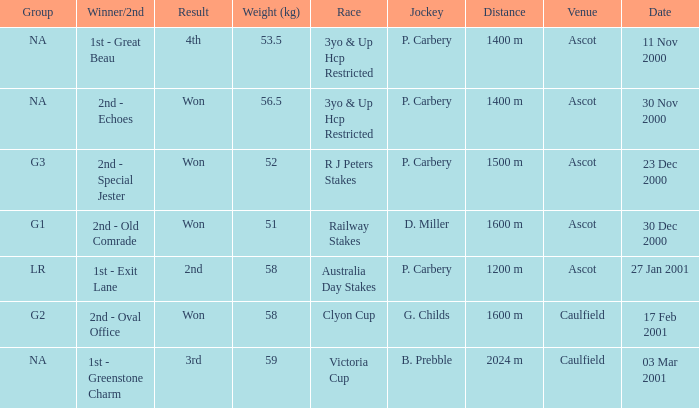What group info is available for the 56.5 kg weight? NA. 